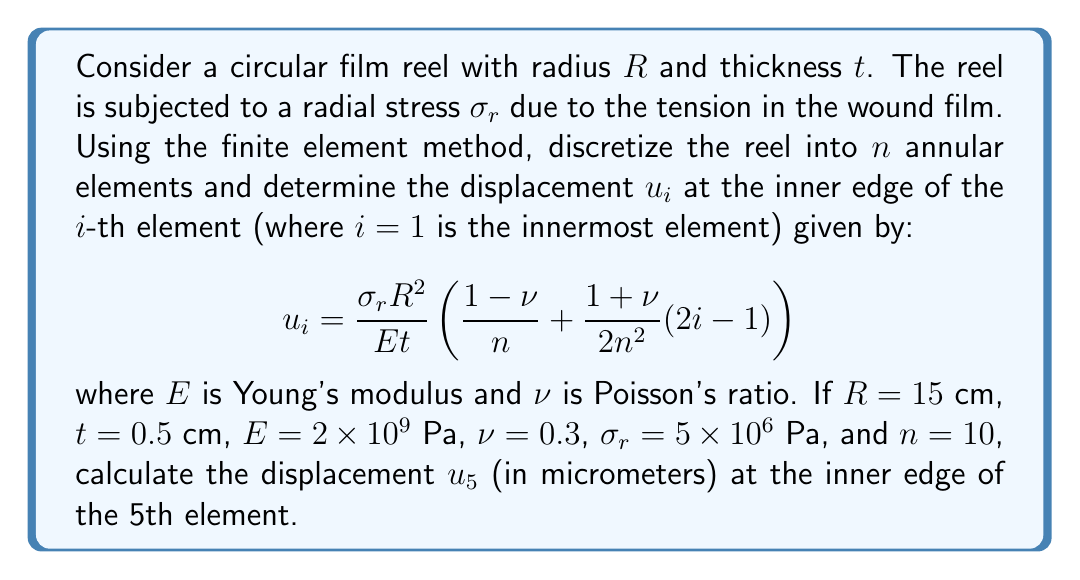What is the answer to this math problem? To solve this problem, we'll follow these steps:

1) First, let's identify the given values:
   $R = 15$ cm = $0.15$ m
   $t = 0.5$ cm = $0.005$ m
   $E = 2 \times 10^9$ Pa
   $\nu = 0.3$
   $\sigma_r = 5 \times 10^6$ Pa
   $n = 10$
   $i = 5$ (for the 5th element)

2) Now, we'll substitute these values into the given equation:

   $$u_i = \frac{\sigma_r R^2}{E t} \left(\frac{1-\nu}{n} + \frac{1+\nu}{2n^2}(2i-1)\right)$$

3) Let's calculate the first part:
   $$\frac{\sigma_r R^2}{E t} = \frac{(5 \times 10^6)(0.15^2)}{(2 \times 10^9)(0.005)} = 1.125 \times 10^{-3}$$

4) Now, let's calculate the terms inside the parentheses:
   $$\frac{1-\nu}{n} = \frac{1-0.3}{10} = 0.07$$
   $$\frac{1+\nu}{2n^2}(2i-1) = \frac{1+0.3}{2(10^2)}(2(5)-1) = 0.0065 \times 9 = 0.0585$$

5) Adding these terms:
   $$0.07 + 0.0585 = 0.1285$$

6) Multiplying this by the result from step 3:
   $$1.125 \times 10^{-3} \times 0.1285 = 1.4456 \times 10^{-4} \text{ m}$$

7) Convert to micrometers:
   $$1.4456 \times 10^{-4} \text{ m} = 144.56 \text{ μm}$$

Therefore, the displacement $u_5$ at the inner edge of the 5th element is approximately 144.56 micrometers.
Answer: 144.56 μm 